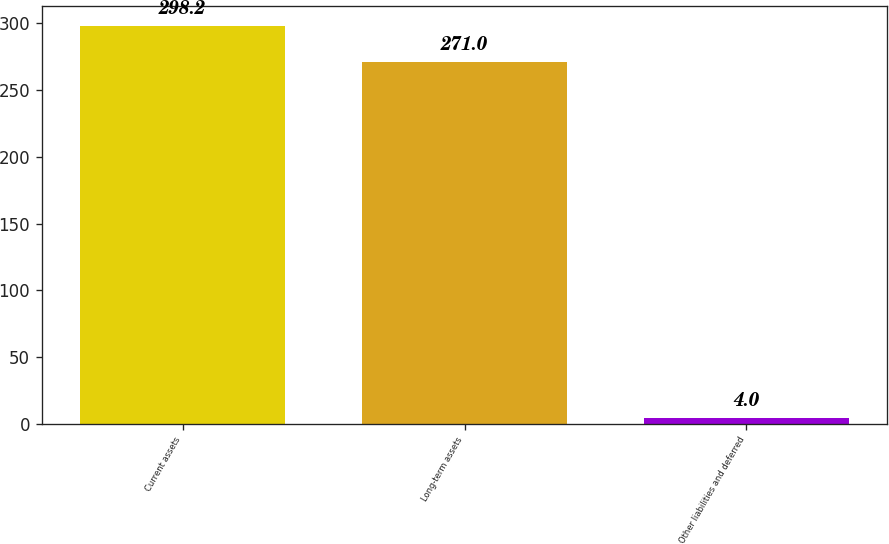Convert chart. <chart><loc_0><loc_0><loc_500><loc_500><bar_chart><fcel>Current assets<fcel>Long-term assets<fcel>Other liabilities and deferred<nl><fcel>298.2<fcel>271<fcel>4<nl></chart> 